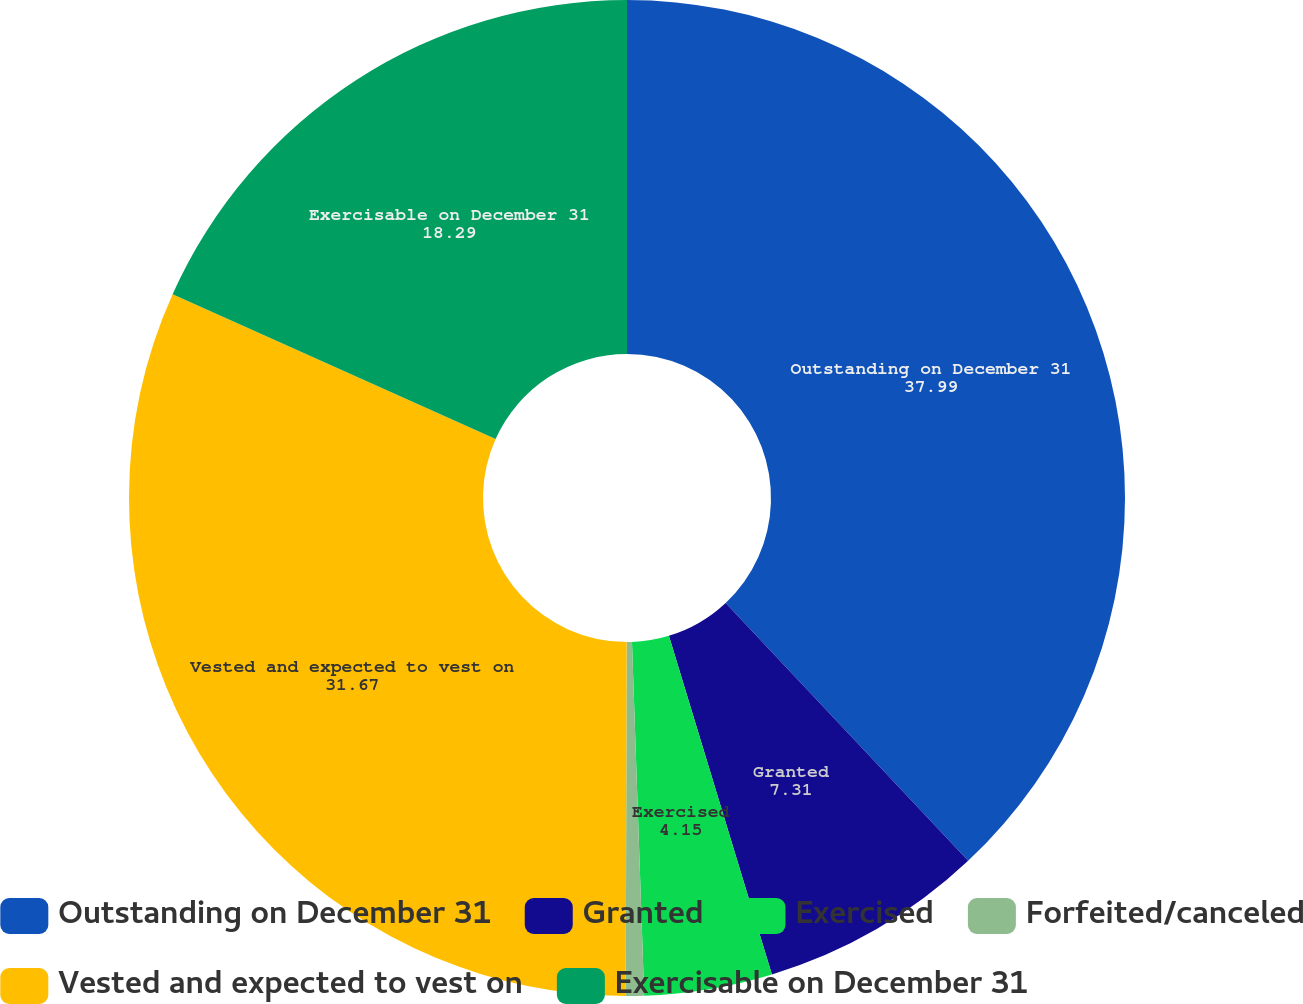Convert chart. <chart><loc_0><loc_0><loc_500><loc_500><pie_chart><fcel>Outstanding on December 31<fcel>Granted<fcel>Exercised<fcel>Forfeited/canceled<fcel>Vested and expected to vest on<fcel>Exercisable on December 31<nl><fcel>37.99%<fcel>7.31%<fcel>4.15%<fcel>0.59%<fcel>31.67%<fcel>18.29%<nl></chart> 